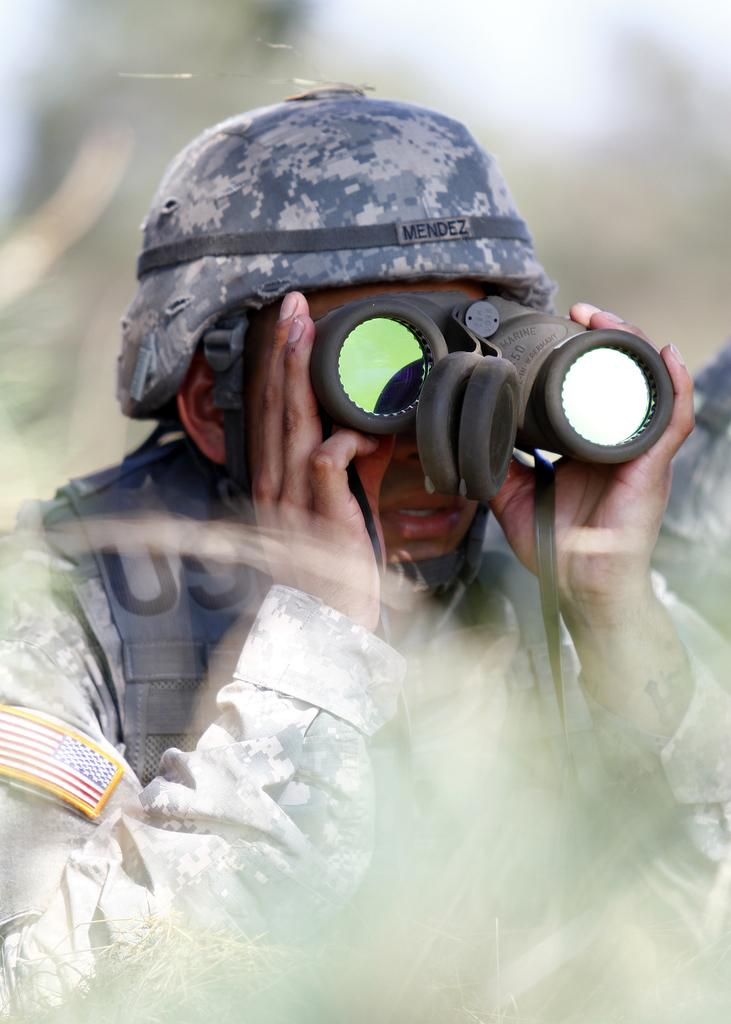What is the main subject of the image? There is a person in the image. What is the person wearing? The person is wearing a uniform and a cap on their head. What is the person doing in the image? The person is watching through binoculars. Can you describe the background of the image? The background of the image is blurred. What type of wound can be seen on the person's arm in the image? There is no wound visible on the person's arm in the image. What act is the person performing in the image? The person is watching through binoculars, but we cannot determine the specific act they are performing. 